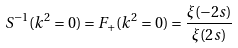<formula> <loc_0><loc_0><loc_500><loc_500>S ^ { - 1 } ( k ^ { 2 } = 0 ) = F _ { + } ( k ^ { 2 } = 0 ) = \frac { \xi ( - 2 s ) } { \xi ( 2 s ) }</formula> 